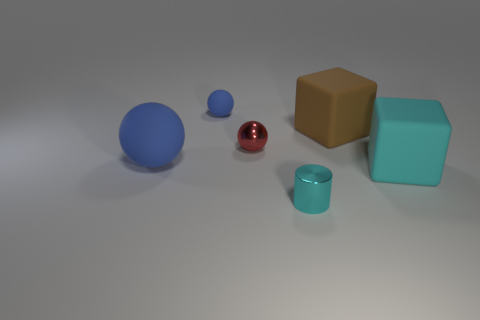Subtract all large spheres. How many spheres are left? 2 Add 4 tiny green rubber objects. How many objects exist? 10 Subtract all red balls. How many balls are left? 2 Add 3 large rubber blocks. How many large rubber blocks exist? 5 Subtract 0 green balls. How many objects are left? 6 Subtract all cylinders. How many objects are left? 5 Subtract 1 balls. How many balls are left? 2 Subtract all purple spheres. Subtract all gray blocks. How many spheres are left? 3 Subtract all yellow cylinders. How many yellow spheres are left? 0 Subtract all tiny cyan things. Subtract all cyan metallic cylinders. How many objects are left? 4 